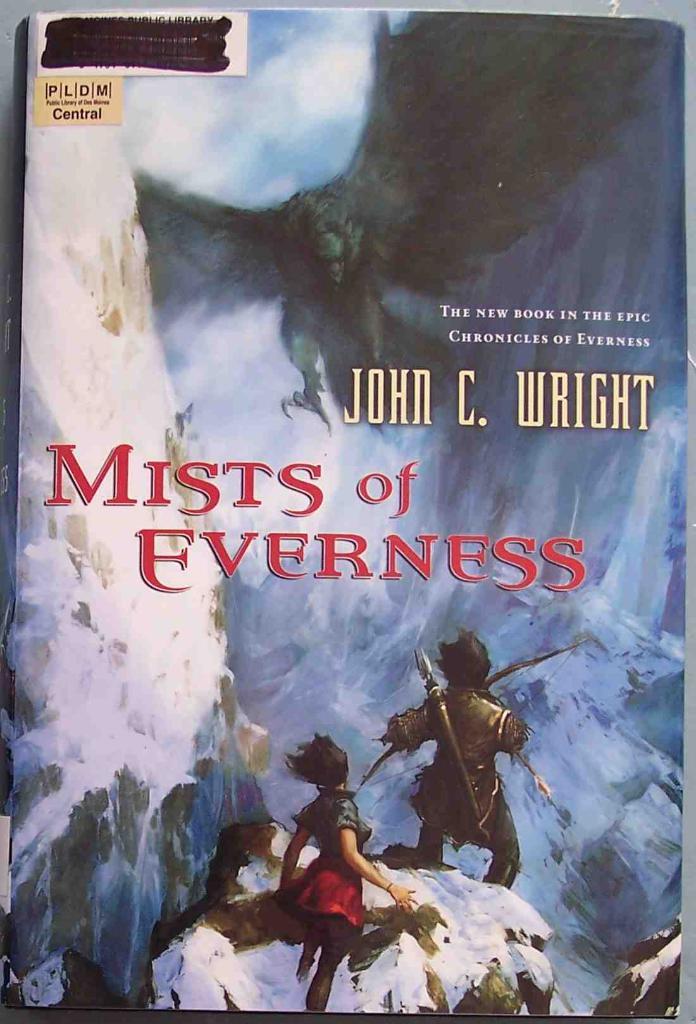Who wrote this book?
Give a very brief answer. John c. wright. What is the title of the book?
Provide a short and direct response. Mists of everness. 